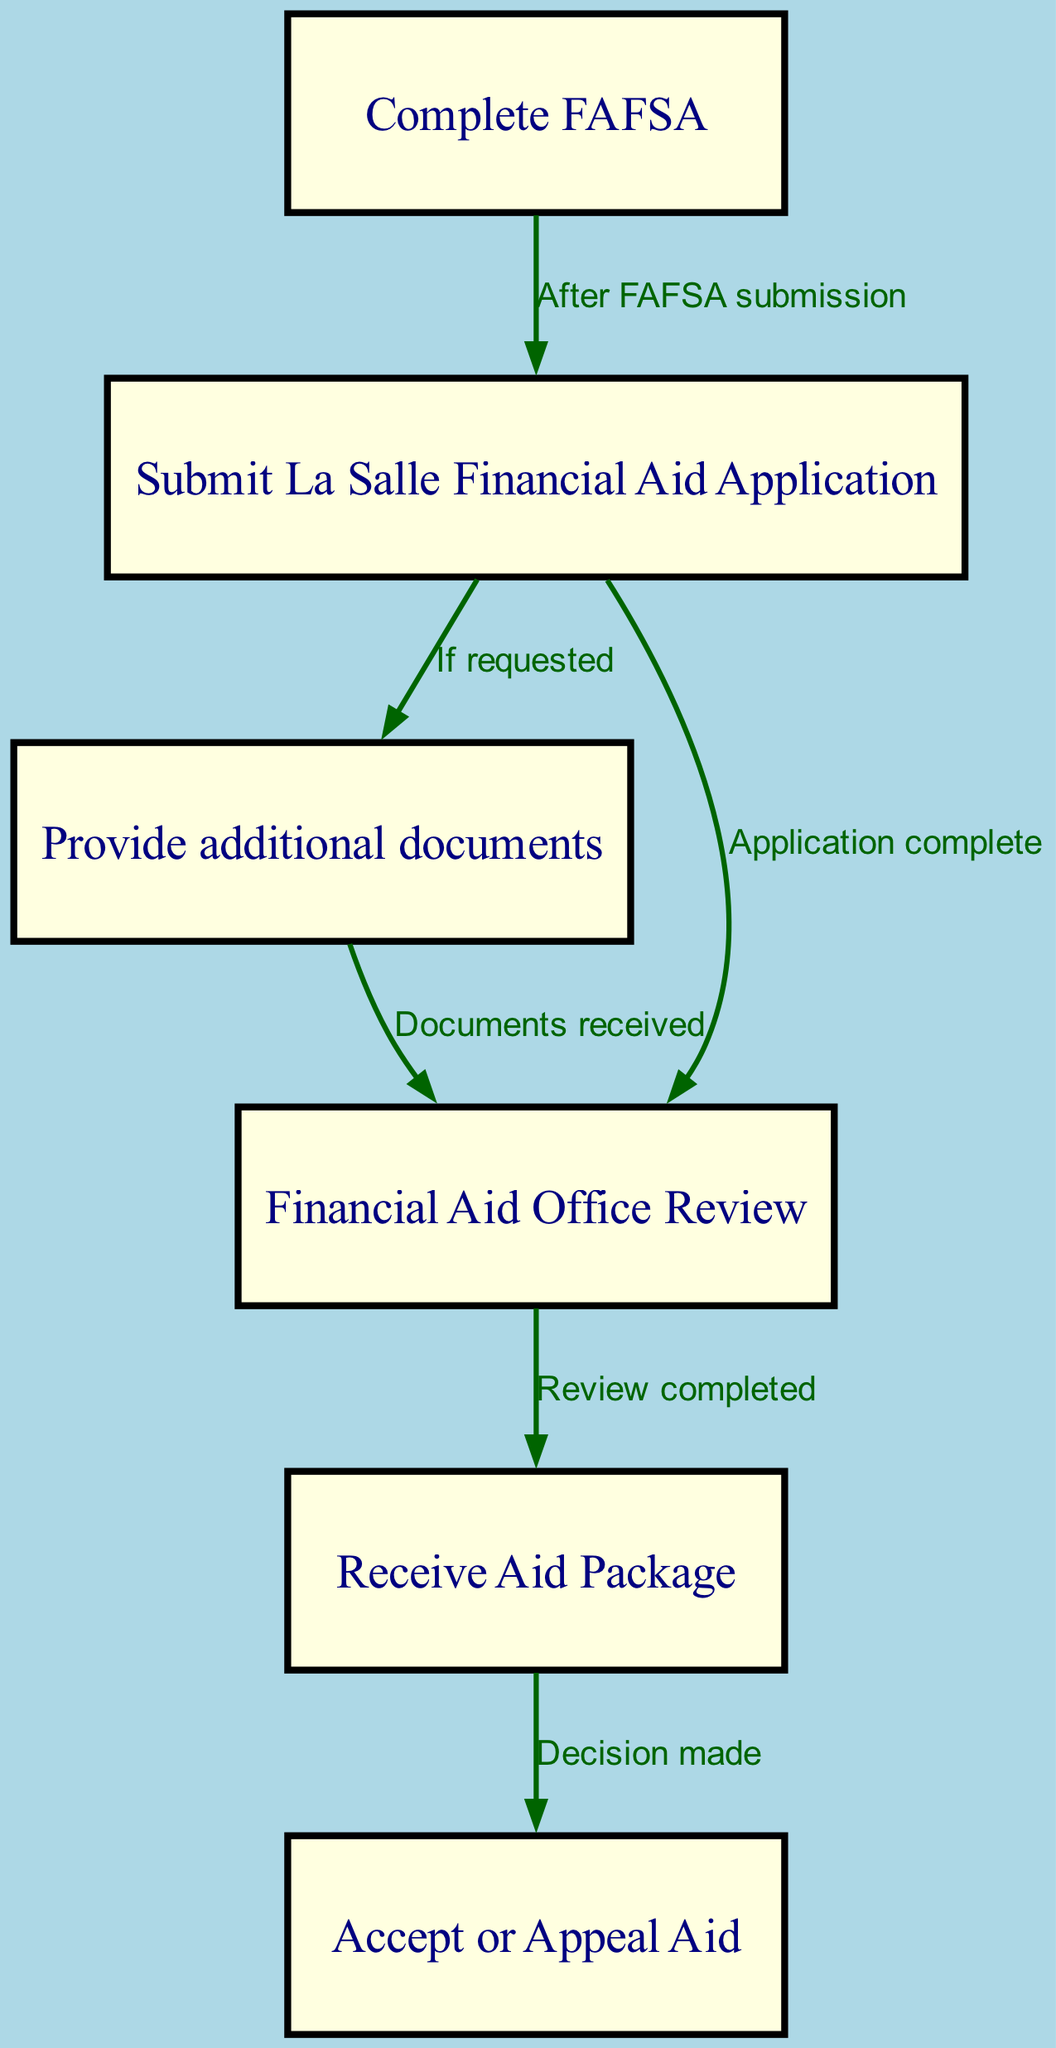What is the first step in the financial aid process at La Salle University? The diagram indicates that the first step is "Complete FAFSA," which is represented as the first node in the flowchart.
Answer: Complete FAFSA How many nodes are present in the diagram? To find the number of nodes, count the distinct elements listed in the nodes section of the data. There are six nodes in total.
Answer: 6 Which step follows after submitting the La Salle Financial Aid Application? The diagram shows that after submitting the La Salle Financial Aid Application, the next step is to "Provide additional documents" if requested, which is illustrated in the flow.
Answer: Provide additional documents What do you do if the Financial Aid Office has completed its review? According to the flowchart, after the Financial Aid Office review is completed, you receive an "Aid Package." This connection is explicitly made in the edges leading from the review node.
Answer: Receive Aid Package What is the action taken after receiving the aid package? The diagram indicates that after receiving the aid package, the next action is to "Accept or Appeal Aid," as this is the subsequent step linked to the preceding node in the flow.
Answer: Accept or Appeal Aid What happens if additional documents are required during the application process? If additional documents are required, the flow indicates that the applicant must provide those documents after submitting the La Salle Financial Aid Application, as this is a conditional path outlined in the diagram.
Answer: Provide additional documents Is it necessary to complete the FAFSA before submitting the La Salle Financial Aid Application? Yes, the edges of the flowchart clearly indicate that completing the FAFSA is a prerequisite before one can submit the La Salle Financial Aid Application.
Answer: Yes What is the relationship between the review completed and the decision made? The flowchart shows a direct connection where the completion of the Financial Aid Office review leads to the next step of making a decision, indicating a sequential relationship between these two stages in the process.
Answer: Review completed leads to Decision made 